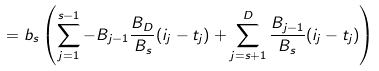<formula> <loc_0><loc_0><loc_500><loc_500>= b _ { s } \left ( \sum _ { j = 1 } ^ { s - 1 } - B _ { j - 1 } \frac { B _ { D } } { B _ { s } } ( i _ { j } - t _ { j } ) + \sum _ { j = s + 1 } ^ { D } \frac { B _ { j - 1 } } { B _ { s } } ( i _ { j } - t _ { j } ) \right )</formula> 